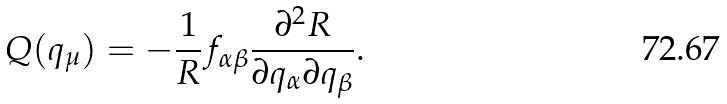Convert formula to latex. <formula><loc_0><loc_0><loc_500><loc_500>Q ( q _ { \mu } ) = - \frac { 1 } { R } f _ { \alpha \beta } \frac { \partial ^ { 2 } R } { \partial q _ { \alpha } \partial q _ { \beta } } .</formula> 